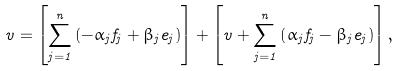<formula> <loc_0><loc_0><loc_500><loc_500>v = \left [ \sum _ { j = 1 } ^ { n } \left ( - \alpha _ { j } f _ { j } + \beta _ { j } e _ { j } \right ) \right ] + \left [ v + \sum _ { j = 1 } ^ { n } \left ( \alpha _ { j } f _ { j } - \beta _ { j } e _ { j } \right ) \right ] ,</formula> 